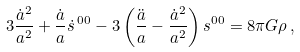<formula> <loc_0><loc_0><loc_500><loc_500>3 \frac { { \dot { a } } ^ { 2 } } { a ^ { 2 } } + \frac { \dot { a } } { a } { \dot { s } } ^ { \, 0 0 } - 3 \left ( \frac { \ddot { a } } { a } - \frac { { \dot { a } } ^ { 2 } } { a ^ { 2 } } \right ) s ^ { 0 0 } = 8 \pi G \rho \, ,</formula> 